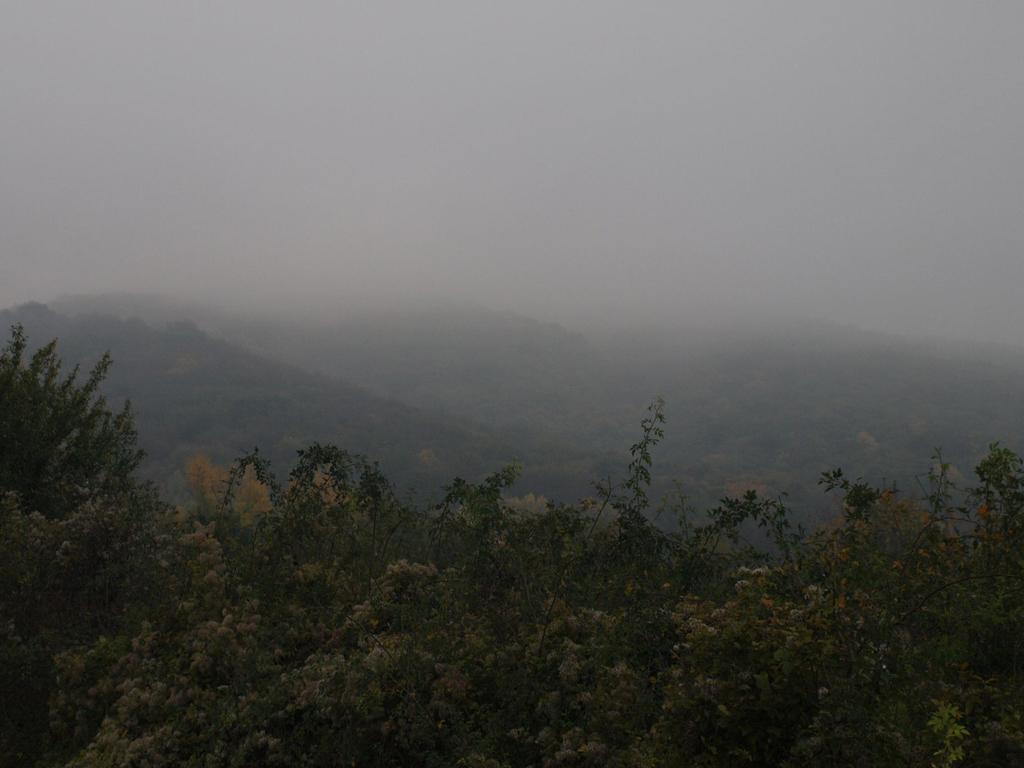Could you give a brief overview of what you see in this image? In this picture there is greenery at the bottom side of the image and there is smoke in the center of the image. 